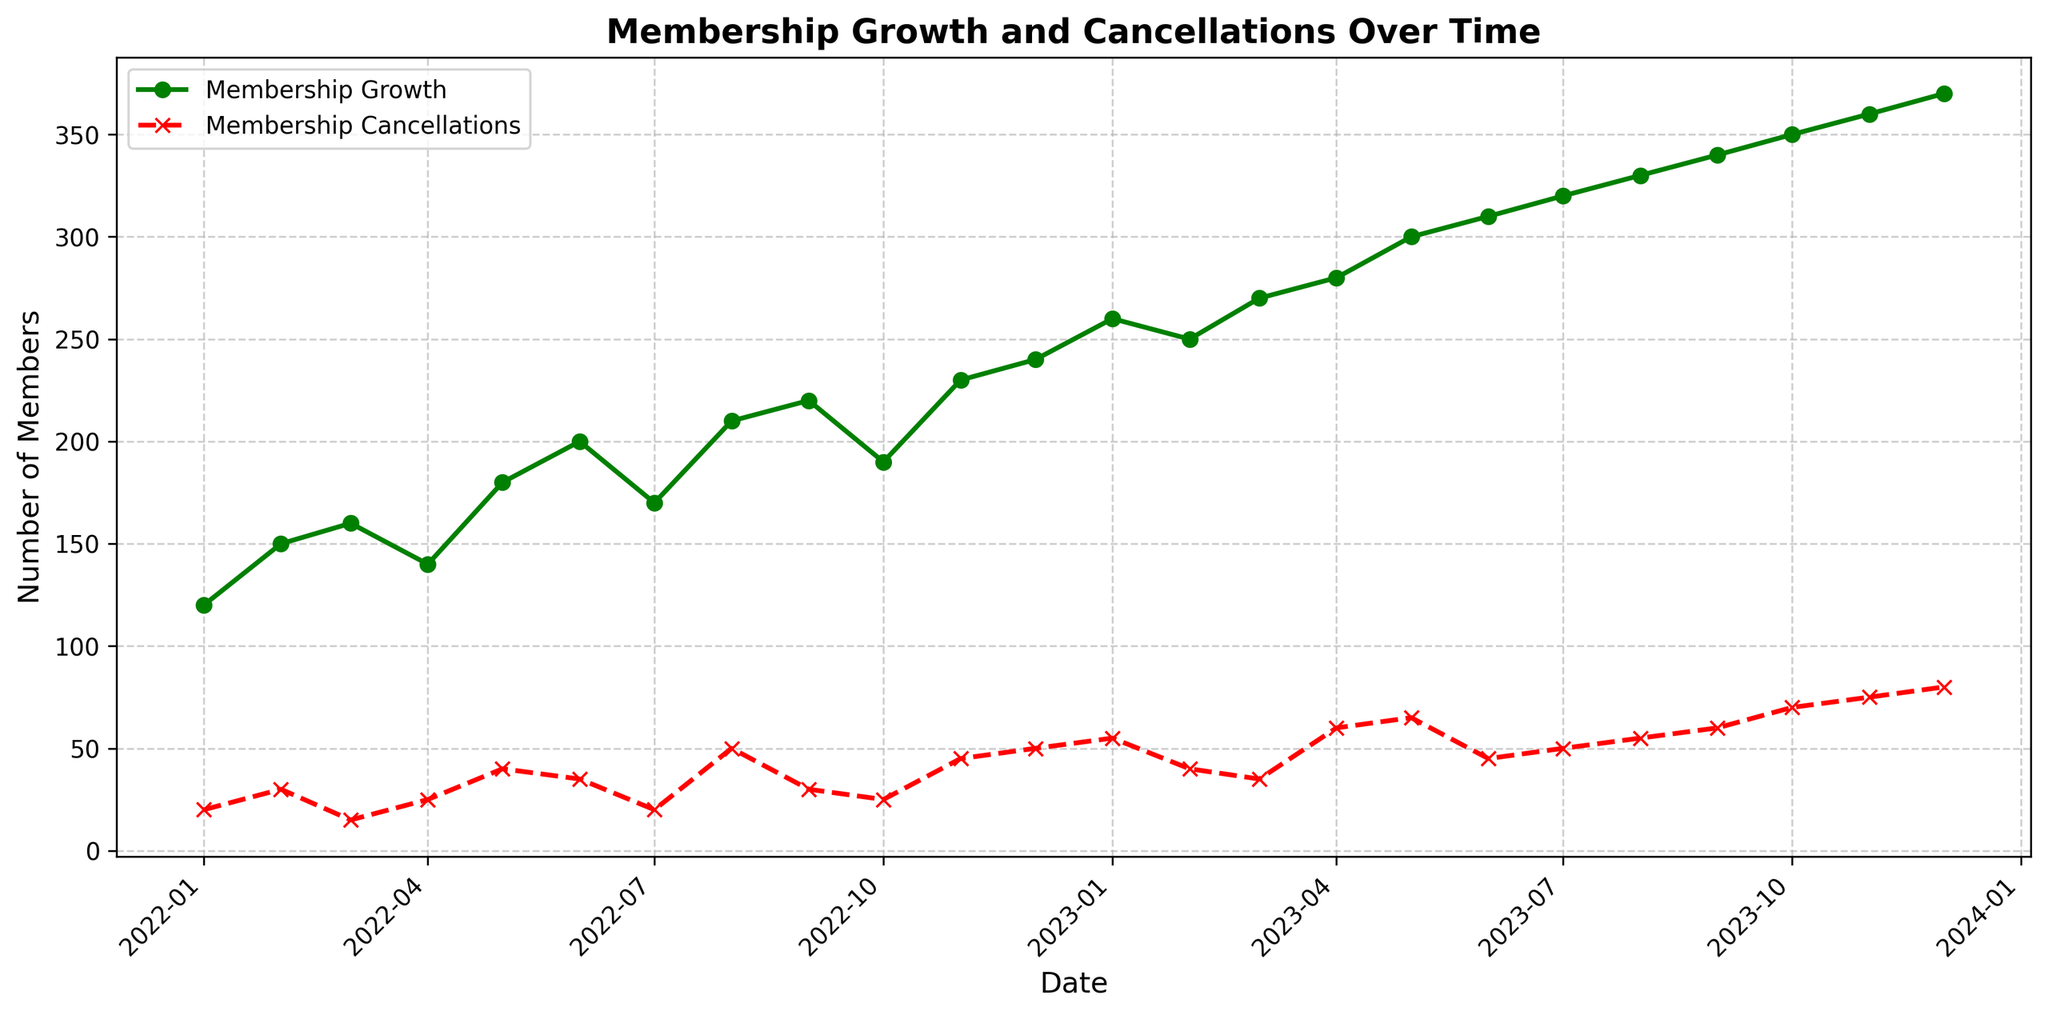What's the difference between Membership Growth and Cancellations in December 2022? In December 2022, Membership Growth is 240, and Membership Cancellations are 50. The difference is 240 - 50.
Answer: 190 Which month had the highest Membership Cancellations, and how many were there? By examining the red line on the plot, the highest Membership Cancellations occurred in December 2023, reaching a peak value.
Answer: December 2023, 80 What is the general trend of Membership Growth over the year 2023? Observing the green line on the plot for the year 2023, the Membership Growth shows an increasing trend throughout the year.
Answer: Increasing During which month does the Membership Cancellations first surpass 60? By looking at the red line, Membership Cancellations first surpass 60 in April 2023.
Answer: April 2023 What is the average Membership Growth from January 2023 to June 2023? The Membership Growth from January 2023 to June 2023 is 260, 250, 270, 280, 300, and 310, respectively. Summing these values and dividing by 6 gives (260 + 250 + 270 + 280 + 300 + 310) / 6 = 278.33.
Answer: 278.33 What's the cumulative Membership Cancellations by the end of 2023? Summing the Membership Cancellations for each month in 2023 gives 55 + 40 + 35 + 60 + 65 + 45 + 50 + 55 + 60 + 70 + 75 + 80 = 690.
Answer: 690 How does the Membership Growth in May 2023 compare to that in May 2022? The Membership Growth in May 2023 is 300, whereas in May 2022, it's 180. Comparing them shows that the number is larger in May 2023.
Answer: 300; it increased How many months had Membership Cancellations below 30? Looking at the figure, the months with Membership Cancellations below 30 are January 2022, March 2022, April 2022, July 2022, September 2022, and October 2022.
Answer: 6 By how much does Membership Growth exceed Membership Cancellations in July 2022? Membership Growth in July 2022 is 170, and Membership Cancellations are 20. The difference is 170 - 20.
Answer: 150 What visual clues can you use to differentiate between the plots of Membership Growth and Cancellations? The Membership Growth line is green with circular markers, while the Membership Cancellations line is red with x-markers. This visual distinction aids in identifying the different data sets.
Answer: Color and marker type 